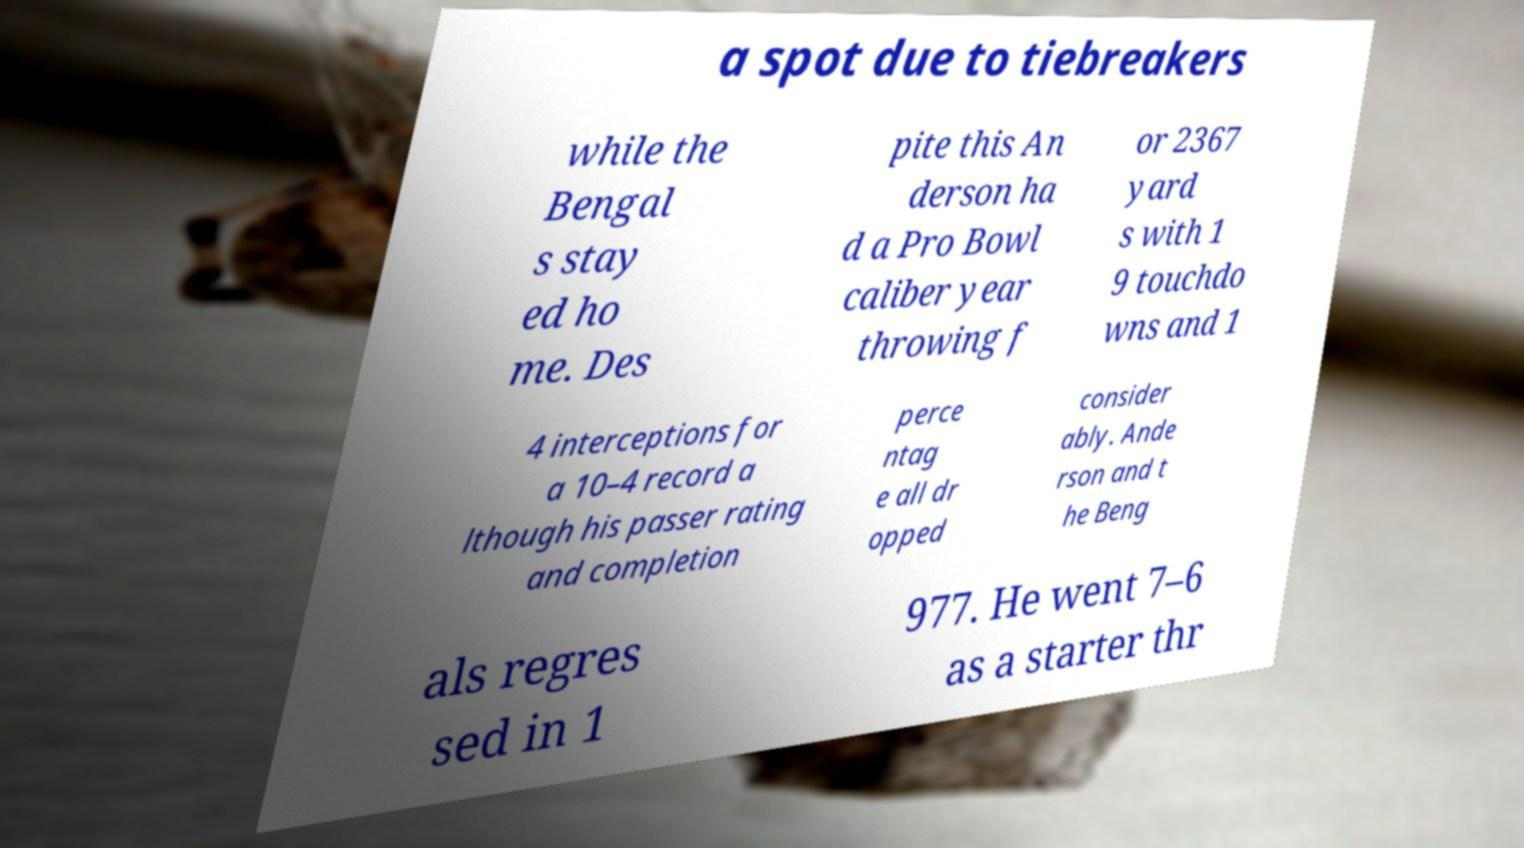Could you extract and type out the text from this image? a spot due to tiebreakers while the Bengal s stay ed ho me. Des pite this An derson ha d a Pro Bowl caliber year throwing f or 2367 yard s with 1 9 touchdo wns and 1 4 interceptions for a 10–4 record a lthough his passer rating and completion perce ntag e all dr opped consider ably. Ande rson and t he Beng als regres sed in 1 977. He went 7–6 as a starter thr 